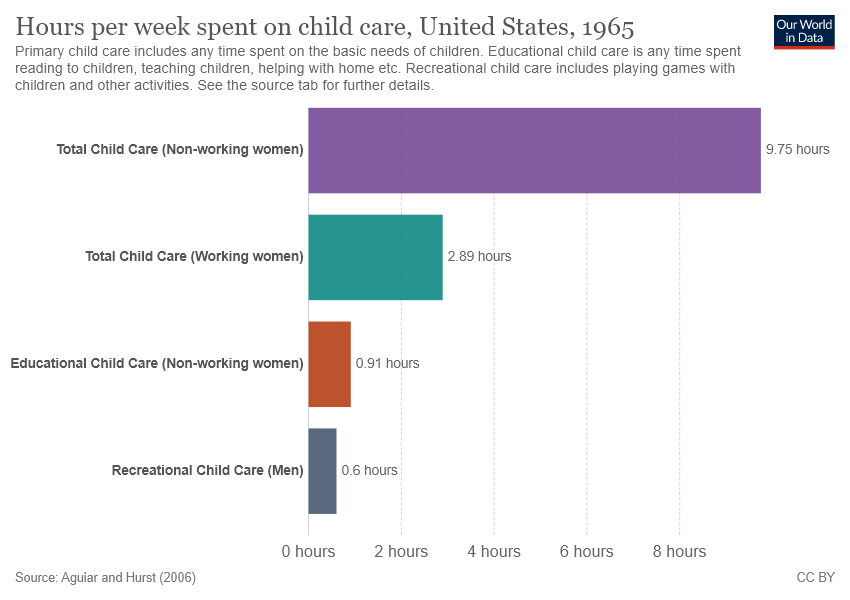Draw attention to some important aspects in this diagram. The value of the longest bar is 9.75. The smallest two bars, which have a value of 0.31, differ in their worth. 